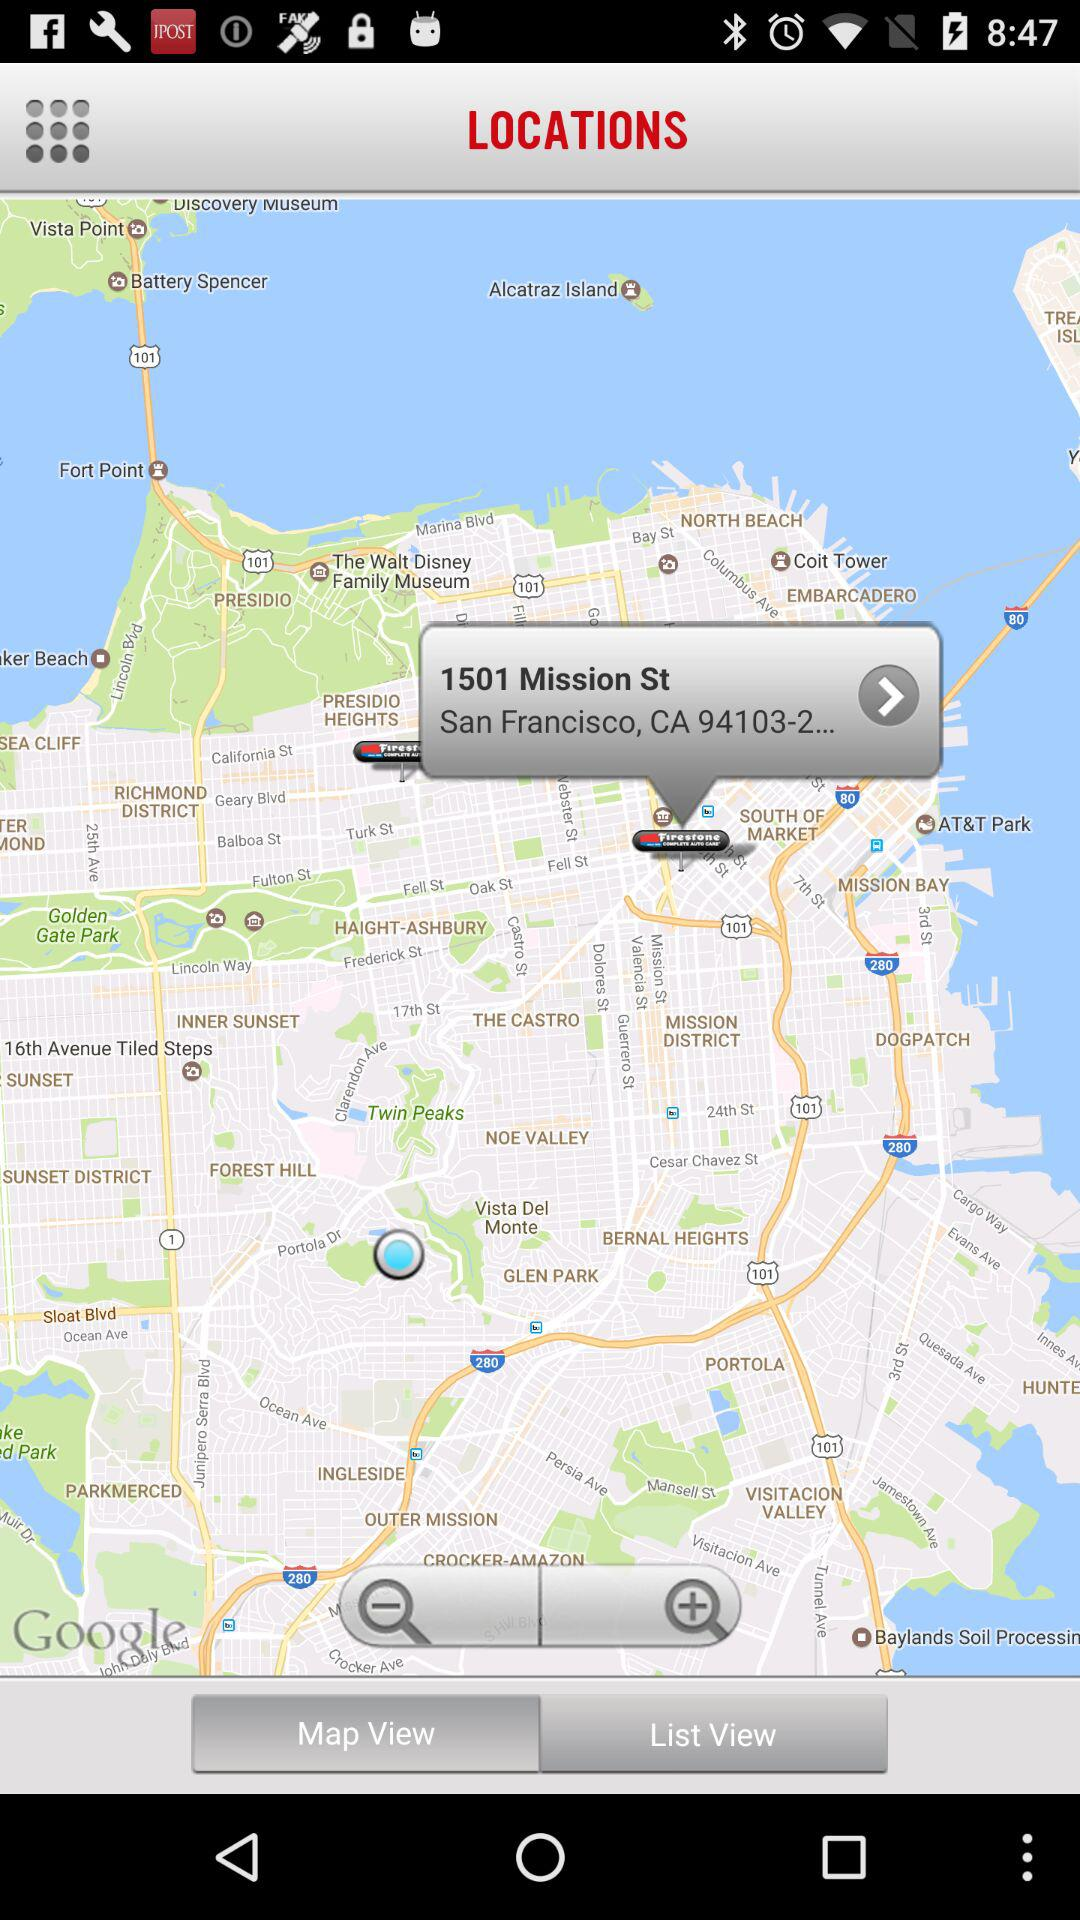What is the mentioned location on the screen? The mentioned location is "1501 Mission St, San Francisco, CA 94103-2...". 